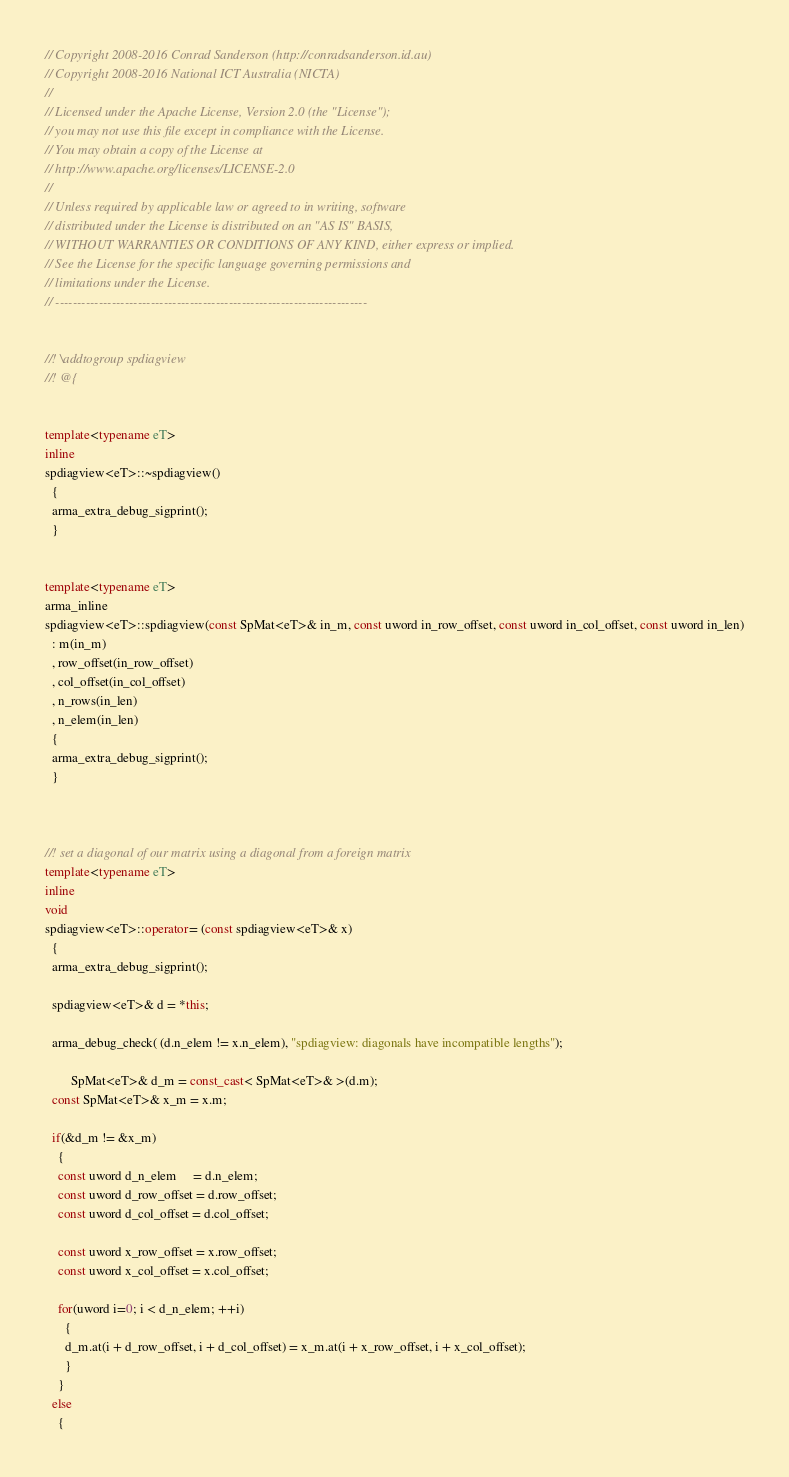<code> <loc_0><loc_0><loc_500><loc_500><_C++_>// Copyright 2008-2016 Conrad Sanderson (http://conradsanderson.id.au)
// Copyright 2008-2016 National ICT Australia (NICTA)
// 
// Licensed under the Apache License, Version 2.0 (the "License");
// you may not use this file except in compliance with the License.
// You may obtain a copy of the License at
// http://www.apache.org/licenses/LICENSE-2.0
// 
// Unless required by applicable law or agreed to in writing, software
// distributed under the License is distributed on an "AS IS" BASIS,
// WITHOUT WARRANTIES OR CONDITIONS OF ANY KIND, either express or implied.
// See the License for the specific language governing permissions and
// limitations under the License.
// ------------------------------------------------------------------------


//! \addtogroup spdiagview
//! @{


template<typename eT>
inline
spdiagview<eT>::~spdiagview()
  {
  arma_extra_debug_sigprint();
  }


template<typename eT>
arma_inline
spdiagview<eT>::spdiagview(const SpMat<eT>& in_m, const uword in_row_offset, const uword in_col_offset, const uword in_len)
  : m(in_m)
  , row_offset(in_row_offset)
  , col_offset(in_col_offset)
  , n_rows(in_len)
  , n_elem(in_len)
  {
  arma_extra_debug_sigprint();
  }



//! set a diagonal of our matrix using a diagonal from a foreign matrix
template<typename eT>
inline
void
spdiagview<eT>::operator= (const spdiagview<eT>& x)
  {
  arma_extra_debug_sigprint();
  
  spdiagview<eT>& d = *this;
  
  arma_debug_check( (d.n_elem != x.n_elem), "spdiagview: diagonals have incompatible lengths");
  
        SpMat<eT>& d_m = const_cast< SpMat<eT>& >(d.m);
  const SpMat<eT>& x_m = x.m;
  
  if(&d_m != &x_m)
    {
    const uword d_n_elem     = d.n_elem;
    const uword d_row_offset = d.row_offset;
    const uword d_col_offset = d.col_offset;
    
    const uword x_row_offset = x.row_offset;
    const uword x_col_offset = x.col_offset;
    
    for(uword i=0; i < d_n_elem; ++i)
      {
      d_m.at(i + d_row_offset, i + d_col_offset) = x_m.at(i + x_row_offset, i + x_col_offset);
      }
    }
  else
    {</code> 